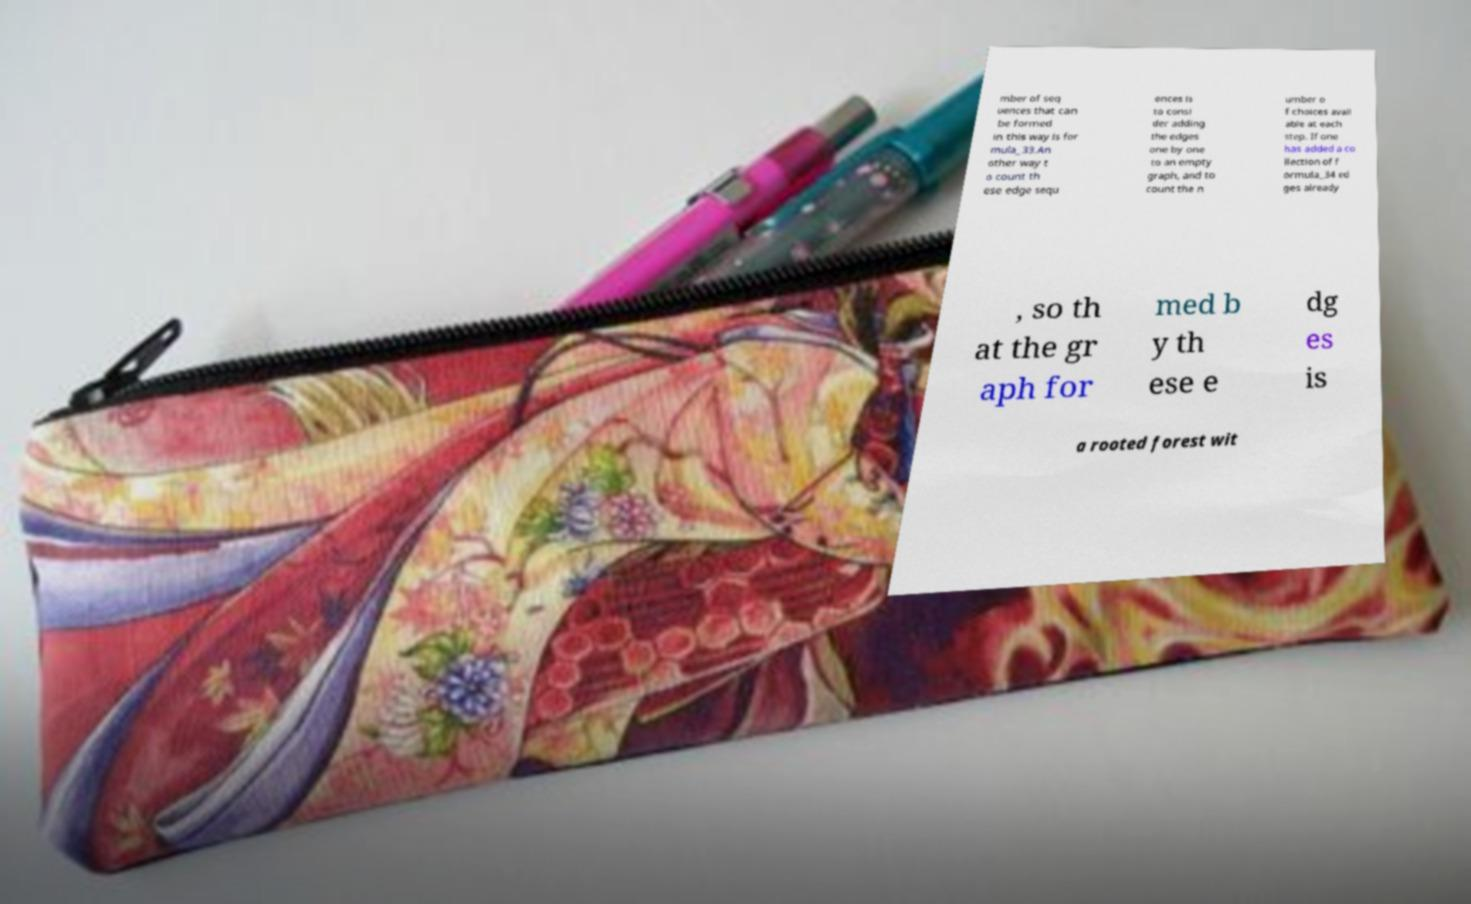I need the written content from this picture converted into text. Can you do that? mber of seq uences that can be formed in this way is for mula_33.An other way t o count th ese edge sequ ences is to consi der adding the edges one by one to an empty graph, and to count the n umber o f choices avail able at each step. If one has added a co llection of f ormula_34 ed ges already , so th at the gr aph for med b y th ese e dg es is a rooted forest wit 